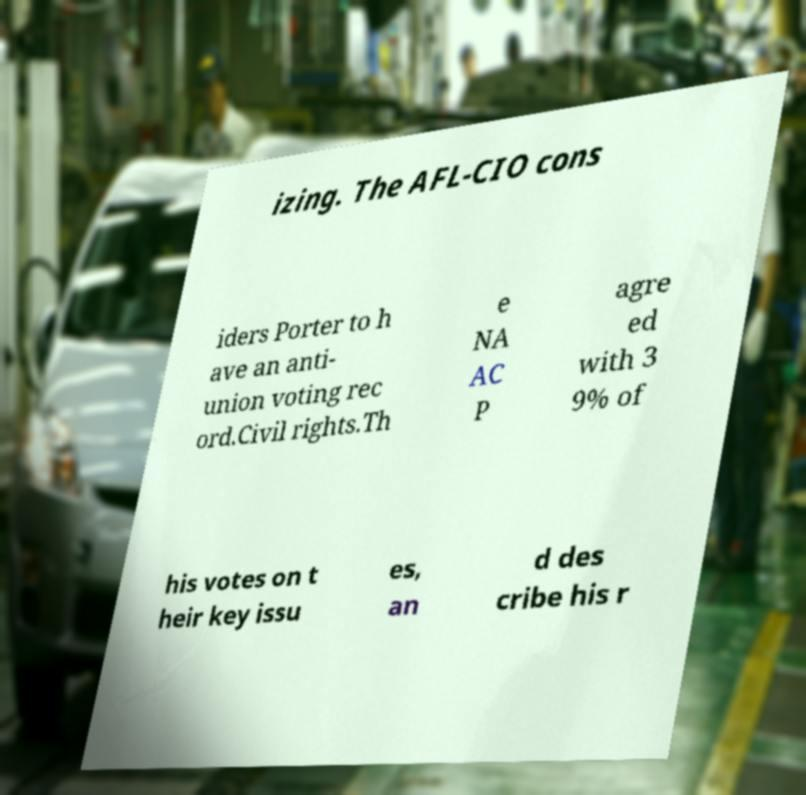Please identify and transcribe the text found in this image. izing. The AFL-CIO cons iders Porter to h ave an anti- union voting rec ord.Civil rights.Th e NA AC P agre ed with 3 9% of his votes on t heir key issu es, an d des cribe his r 